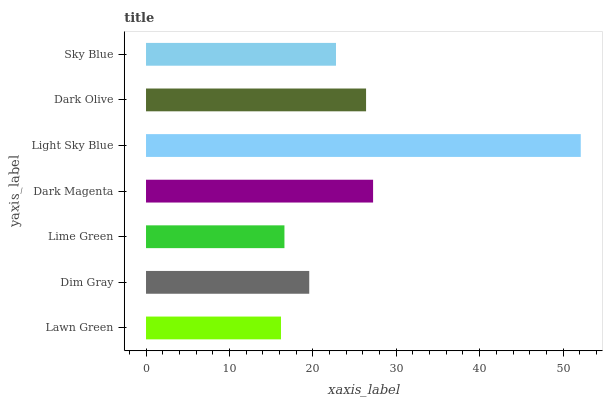Is Lawn Green the minimum?
Answer yes or no. Yes. Is Light Sky Blue the maximum?
Answer yes or no. Yes. Is Dim Gray the minimum?
Answer yes or no. No. Is Dim Gray the maximum?
Answer yes or no. No. Is Dim Gray greater than Lawn Green?
Answer yes or no. Yes. Is Lawn Green less than Dim Gray?
Answer yes or no. Yes. Is Lawn Green greater than Dim Gray?
Answer yes or no. No. Is Dim Gray less than Lawn Green?
Answer yes or no. No. Is Sky Blue the high median?
Answer yes or no. Yes. Is Sky Blue the low median?
Answer yes or no. Yes. Is Lime Green the high median?
Answer yes or no. No. Is Light Sky Blue the low median?
Answer yes or no. No. 